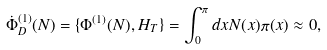Convert formula to latex. <formula><loc_0><loc_0><loc_500><loc_500>\dot { \Phi } _ { D } ^ { ( 1 ) } ( N ) = \{ \Phi ^ { ( 1 ) } ( N ) , H _ { T } \} = \int _ { 0 } ^ { \pi } d x N ( x ) \pi ( x ) \approx 0 ,</formula> 